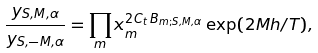<formula> <loc_0><loc_0><loc_500><loc_500>\frac { y _ { S , M , \alpha } } { y _ { S , - M , \alpha } } = \prod _ { m } x _ { m } ^ { 2 C _ { t } \, B _ { m ; S , M , \alpha } } \exp ( 2 M h / T ) ,</formula> 